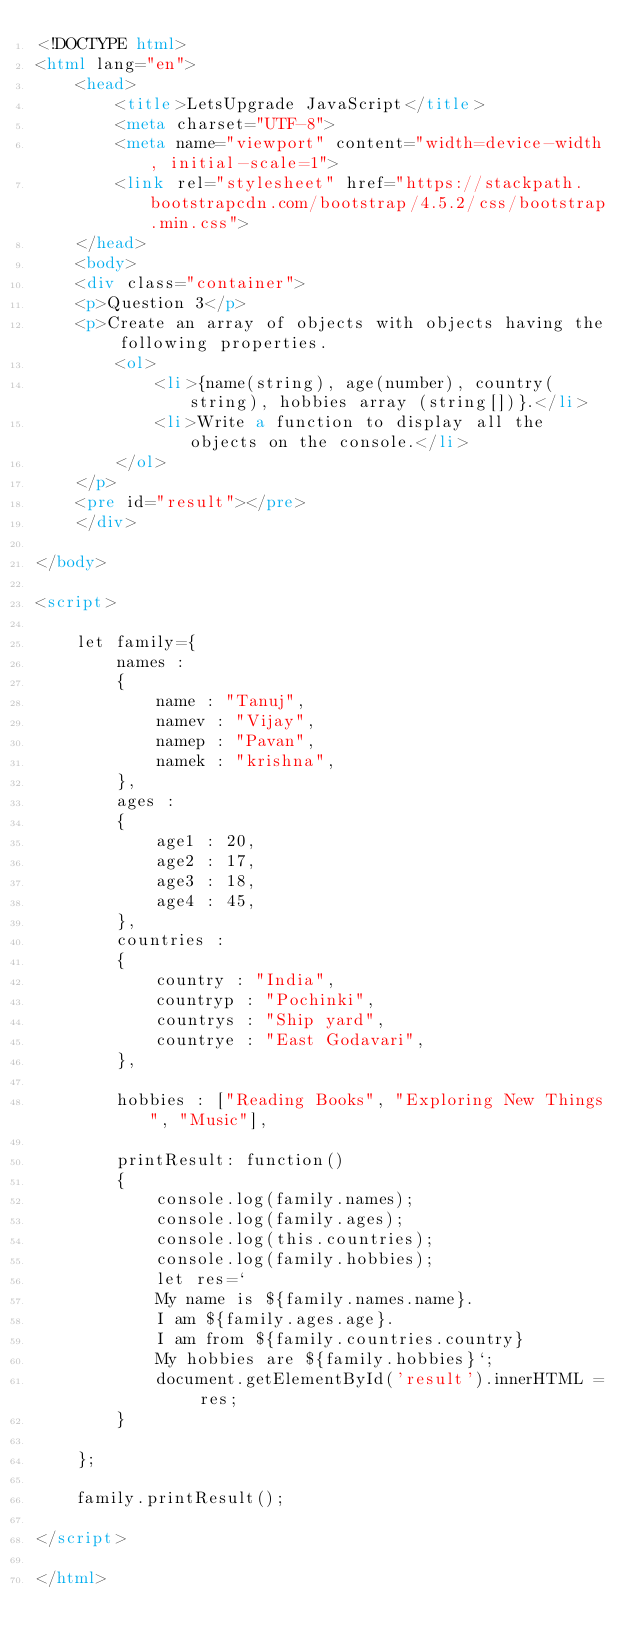Convert code to text. <code><loc_0><loc_0><loc_500><loc_500><_HTML_><!DOCTYPE html>
<html lang="en">
    <head>
        <title>LetsUpgrade JavaScript</title>
        <meta charset="UTF-8">
        <meta name="viewport" content="width=device-width, initial-scale=1">
        <link rel="stylesheet" href="https://stackpath.bootstrapcdn.com/bootstrap/4.5.2/css/bootstrap.min.css">
    </head>
    <body>
    <div class="container">
    <p>Question 3</p>
    <p>Create an array of objects with objects having the following properties.
        <ol>
            <li>{name(string), age(number), country(string), hobbies array (string[])}.</li>
            <li>Write a function to display all the objects on the console.</li>
        </ol>
    </p>
    <pre id="result"></pre>
    </div>

</body>

<script>

    let family={
        names :
        {
            name : "Tanuj",
            namev : "Vijay",
            namep : "Pavan",
            namek : "krishna",
        },
        ages :
        {
            age1 : 20,
            age2 : 17,
            age3 : 18,
            age4 : 45,
        },
        countries :
        {
            country : "India",
            countryp : "Pochinki",
            countrys : "Ship yard",
            countrye : "East Godavari",
        },

        hobbies : ["Reading Books", "Exploring New Things", "Music"],

        printResult: function()
        {
            console.log(family.names);
            console.log(family.ages);
            console.log(this.countries);
            console.log(family.hobbies);
            let res=`
            My name is ${family.names.name}.
            I am ${family.ages.age}.
            I am from ${family.countries.country}
            My hobbies are ${family.hobbies}`;
            document.getElementById('result').innerHTML = res;
        }

    };

    family.printResult();

</script>

</html></code> 